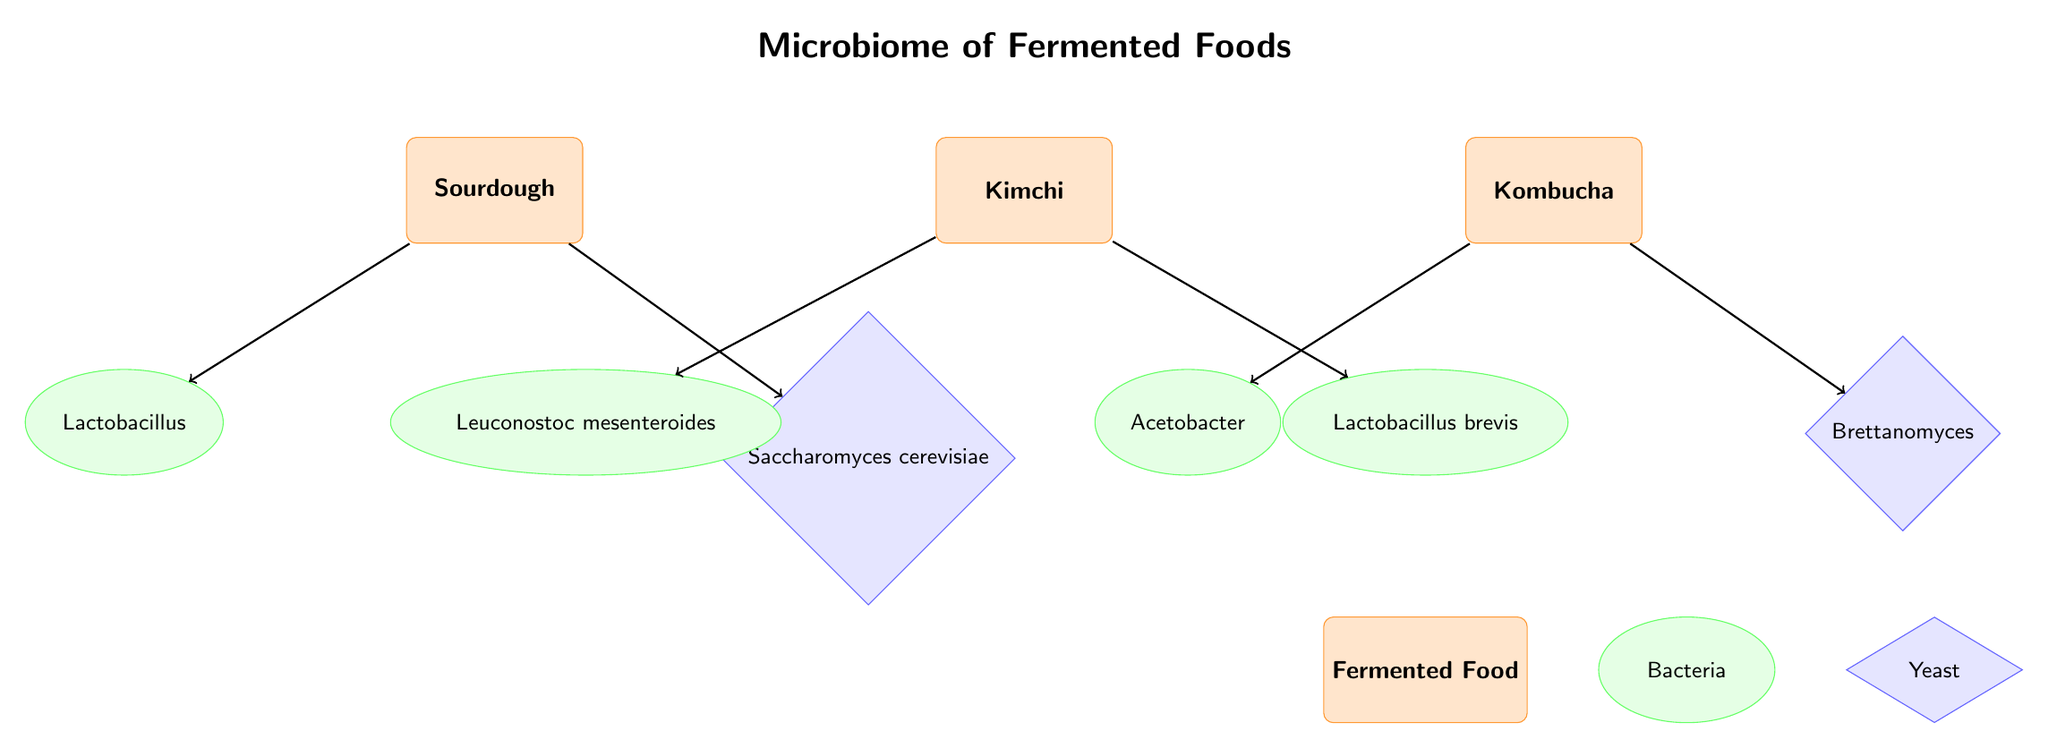What are the two main types of microorganisms involved in sourdough fermentation? The diagram shows two nodes connected to sourdough: Lactobacillus and Saccharomyces cerevisiae. These nodes represent the two main types of microorganisms involved in its fermentation process.
Answer: Lactobacillus and Saccharomyces cerevisiae Which food does Leuconostoc mesenteroides ferment? The diagram indicates that Leuconostoc mesenteroides is connected to the kimchi node, which implies that this bacterium is involved in the fermentation of kimchi.
Answer: Kimchi How many bacterial species are involved in the fermentation processes shown? By counting the bacterial nodes in the diagram, we see two for sourdough (Lactobacillus), two for kimchi (Leuconostoc mesenteroides and Lactobacillus brevis), and one for kombucha (Acetobacter). This results in a total of five bacterial species.
Answer: 5 Which yeast is associated with kombucha? The diagram shows that Brettanomyces is the yeast connected to the kombucha node, indicating that it is the yeast involved in kombucha fermentation.
Answer: Brettanomyces What is the relationship between Sourdough and Saccharomyces cerevisiae? The diagram has an arrow (edge) pointing from sourdough to Saccharomyces cerevisiae, indicating that this yeast is utilized in the fermentation process of sourdough.
Answer: Utilizes 